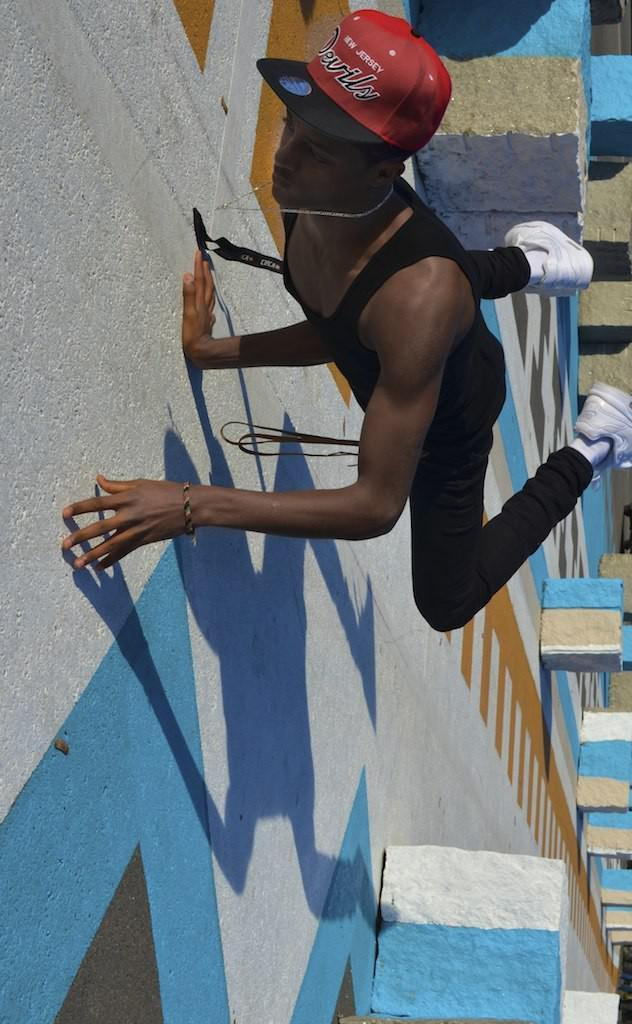Who is the main subject in the image? There is a boy in the image. What is the boy wearing? The boy is wearing black jeans and a red cap. What is the boy doing in the image? The boy is doing stunts. How is the road in the image decorated? The road in the image is white and blue painted. What can be seen in the background of the image? There are concrete blocks visible in the background. What type of cheese is the boy eating in the image? There is no cheese present in the image; the boy is doing stunts. What kind of cabbage is growing in the background of the image? There is no cabbage present in the image; the background features concrete blocks. 